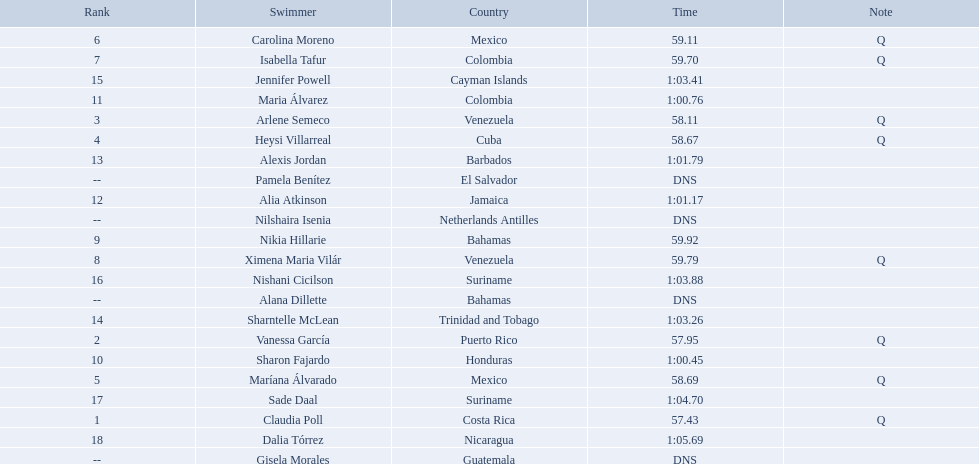Who were the swimmers at the 2006 central american and caribbean games - women's 100 metre freestyle? Claudia Poll, Vanessa García, Arlene Semeco, Heysi Villarreal, Maríana Álvarado, Carolina Moreno, Isabella Tafur, Ximena Maria Vilár, Nikia Hillarie, Sharon Fajardo, Maria Álvarez, Alia Atkinson, Alexis Jordan, Sharntelle McLean, Jennifer Powell, Nishani Cicilson, Sade Daal, Dalia Tórrez, Gisela Morales, Alana Dillette, Pamela Benítez, Nilshaira Isenia. Of these which were from cuba? Heysi Villarreal. Who were all of the swimmers in the women's 100 metre freestyle? Claudia Poll, Vanessa García, Arlene Semeco, Heysi Villarreal, Maríana Álvarado, Carolina Moreno, Isabella Tafur, Ximena Maria Vilár, Nikia Hillarie, Sharon Fajardo, Maria Álvarez, Alia Atkinson, Alexis Jordan, Sharntelle McLean, Jennifer Powell, Nishani Cicilson, Sade Daal, Dalia Tórrez, Gisela Morales, Alana Dillette, Pamela Benítez, Nilshaira Isenia. Where was each swimmer from? Costa Rica, Puerto Rico, Venezuela, Cuba, Mexico, Mexico, Colombia, Venezuela, Bahamas, Honduras, Colombia, Jamaica, Barbados, Trinidad and Tobago, Cayman Islands, Suriname, Suriname, Nicaragua, Guatemala, Bahamas, El Salvador, Netherlands Antilles. What were their ranks? 1, 2, 3, 4, 5, 6, 7, 8, 9, 10, 11, 12, 13, 14, 15, 16, 17, 18, --, --, --, --. Who was in the top eight? Claudia Poll, Vanessa García, Arlene Semeco, Heysi Villarreal, Maríana Álvarado, Carolina Moreno, Isabella Tafur, Ximena Maria Vilár. Of those swimmers, which one was from cuba? Heysi Villarreal. 